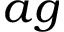<formula> <loc_0><loc_0><loc_500><loc_500>a g</formula> 